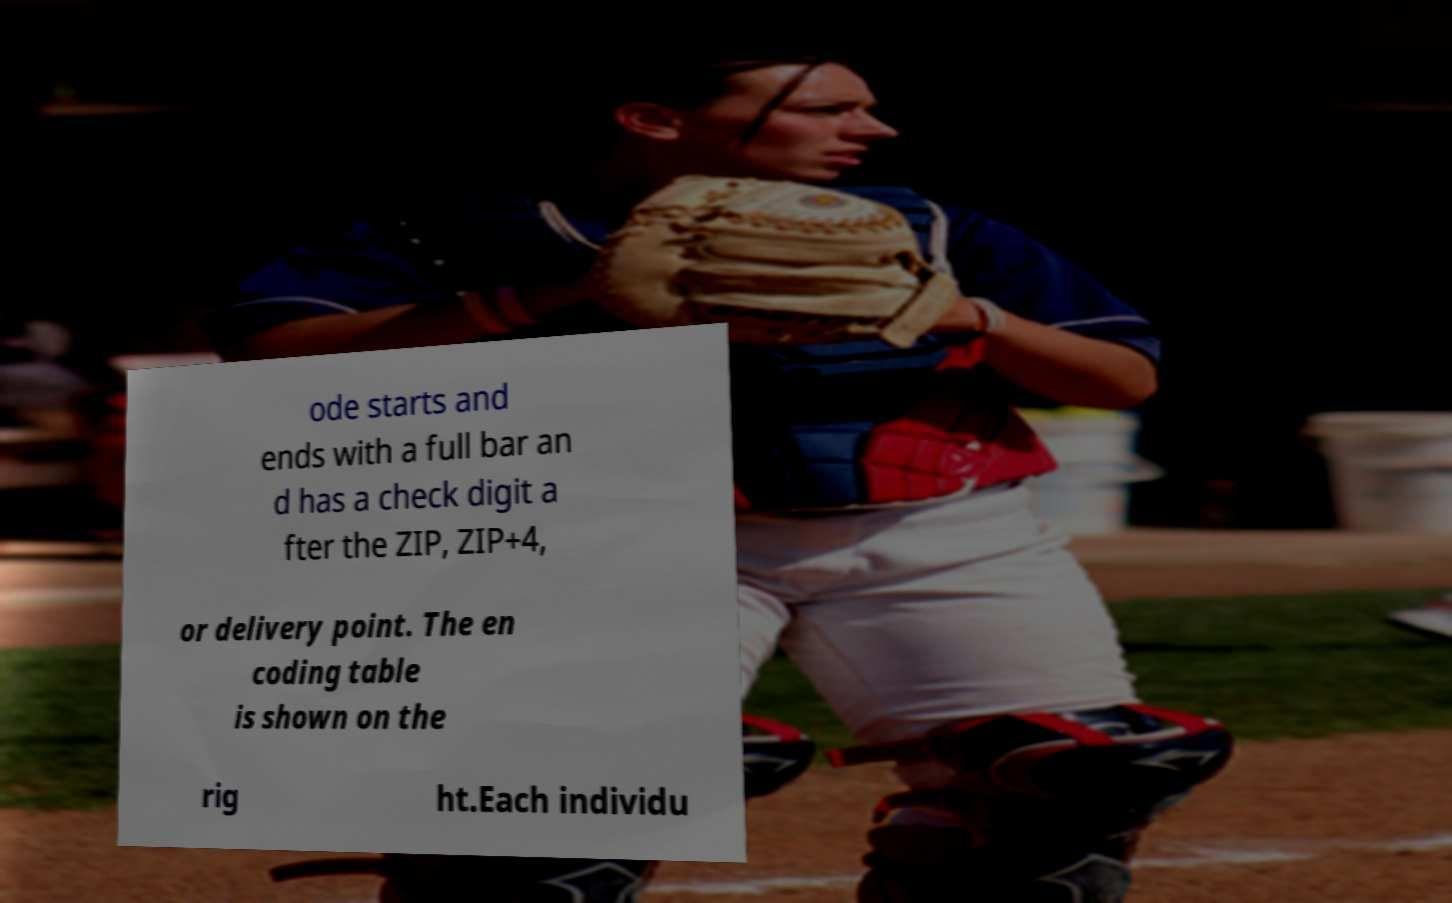Please read and relay the text visible in this image. What does it say? ode starts and ends with a full bar an d has a check digit a fter the ZIP, ZIP+4, or delivery point. The en coding table is shown on the rig ht.Each individu 